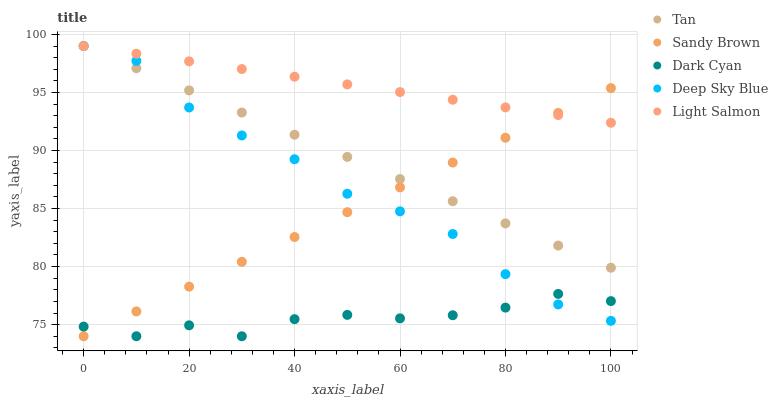Does Dark Cyan have the minimum area under the curve?
Answer yes or no. Yes. Does Light Salmon have the maximum area under the curve?
Answer yes or no. Yes. Does Tan have the minimum area under the curve?
Answer yes or no. No. Does Tan have the maximum area under the curve?
Answer yes or no. No. Is Light Salmon the smoothest?
Answer yes or no. Yes. Is Dark Cyan the roughest?
Answer yes or no. Yes. Is Tan the smoothest?
Answer yes or no. No. Is Tan the roughest?
Answer yes or no. No. Does Dark Cyan have the lowest value?
Answer yes or no. Yes. Does Tan have the lowest value?
Answer yes or no. No. Does Deep Sky Blue have the highest value?
Answer yes or no. Yes. Does Sandy Brown have the highest value?
Answer yes or no. No. Is Dark Cyan less than Light Salmon?
Answer yes or no. Yes. Is Light Salmon greater than Dark Cyan?
Answer yes or no. Yes. Does Light Salmon intersect Sandy Brown?
Answer yes or no. Yes. Is Light Salmon less than Sandy Brown?
Answer yes or no. No. Is Light Salmon greater than Sandy Brown?
Answer yes or no. No. Does Dark Cyan intersect Light Salmon?
Answer yes or no. No. 